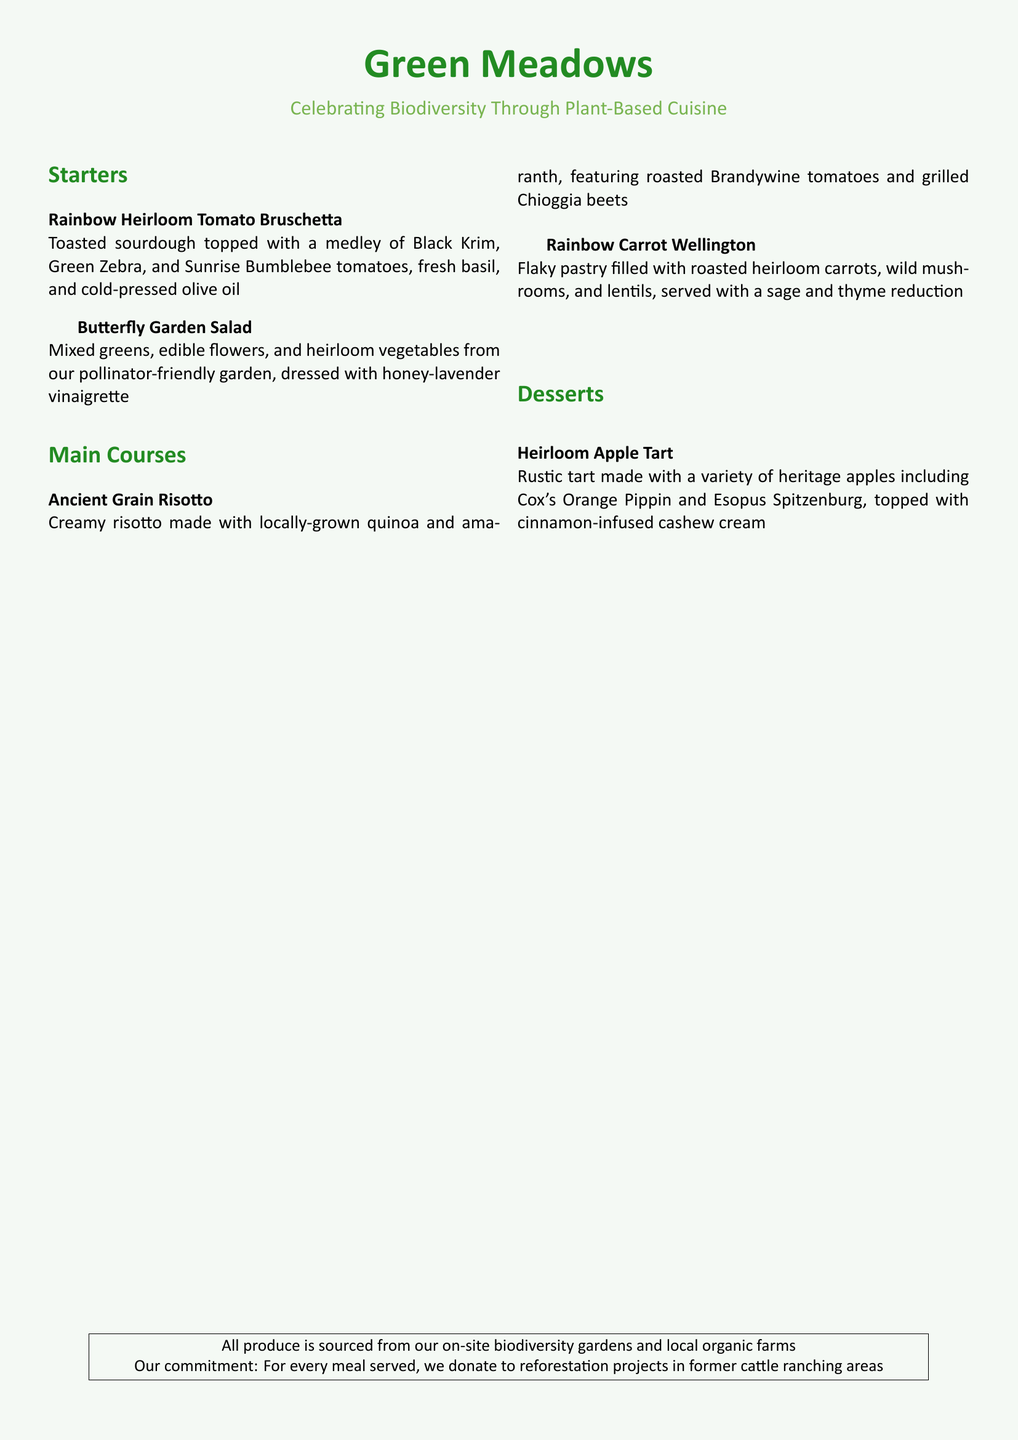What is the name of the restaurant? The name of the restaurant is highlighted at the top of the document in bold and large font.
Answer: Green Meadows What type of cuisine does the menu celebrate? The document mentions the type of cuisine that highlights the restaurant's focus on nature and agriculture.
Answer: Plant-Based Cuisine What is included in the Rainbow Heirloom Tomato Bruschetta? This dish is described in the starters section, listing its key ingredients.
Answer: Black Krim, Green Zebra, Sunrise Bumblebee tomatoes, fresh basil, cold-pressed olive oil What is the dressing for the Butterfly Garden Salad? The dressing for this salad is specifically mentioned in the descrition provided in the document.
Answer: Honey-lavender vinaigrette What is the main ingredient in the Ancient Grain Risotto? The main ingredient is indicated as a highlight in the dish introduction.
Answer: Locally-grown quinoa and amaranth How many desserts are listed on the menu? The menu presents desserts, and this question counts them.
Answer: One What type of apples are used in the Heirloom Apple Tart? The document details the type of apples included in the tart recipe.
Answer: Heritage apples What is the restaurant's commitment regarding meals served? The commitment is stated in the section at the bottom of the document, underlining social responsibility.
Answer: Donates to reforestation projects What garden principle is emphasized in the Butterfly Garden Salad? The description of this dish highlights a specific gardening practice that supports wildlife.
Answer: Pollinator-friendly garden 